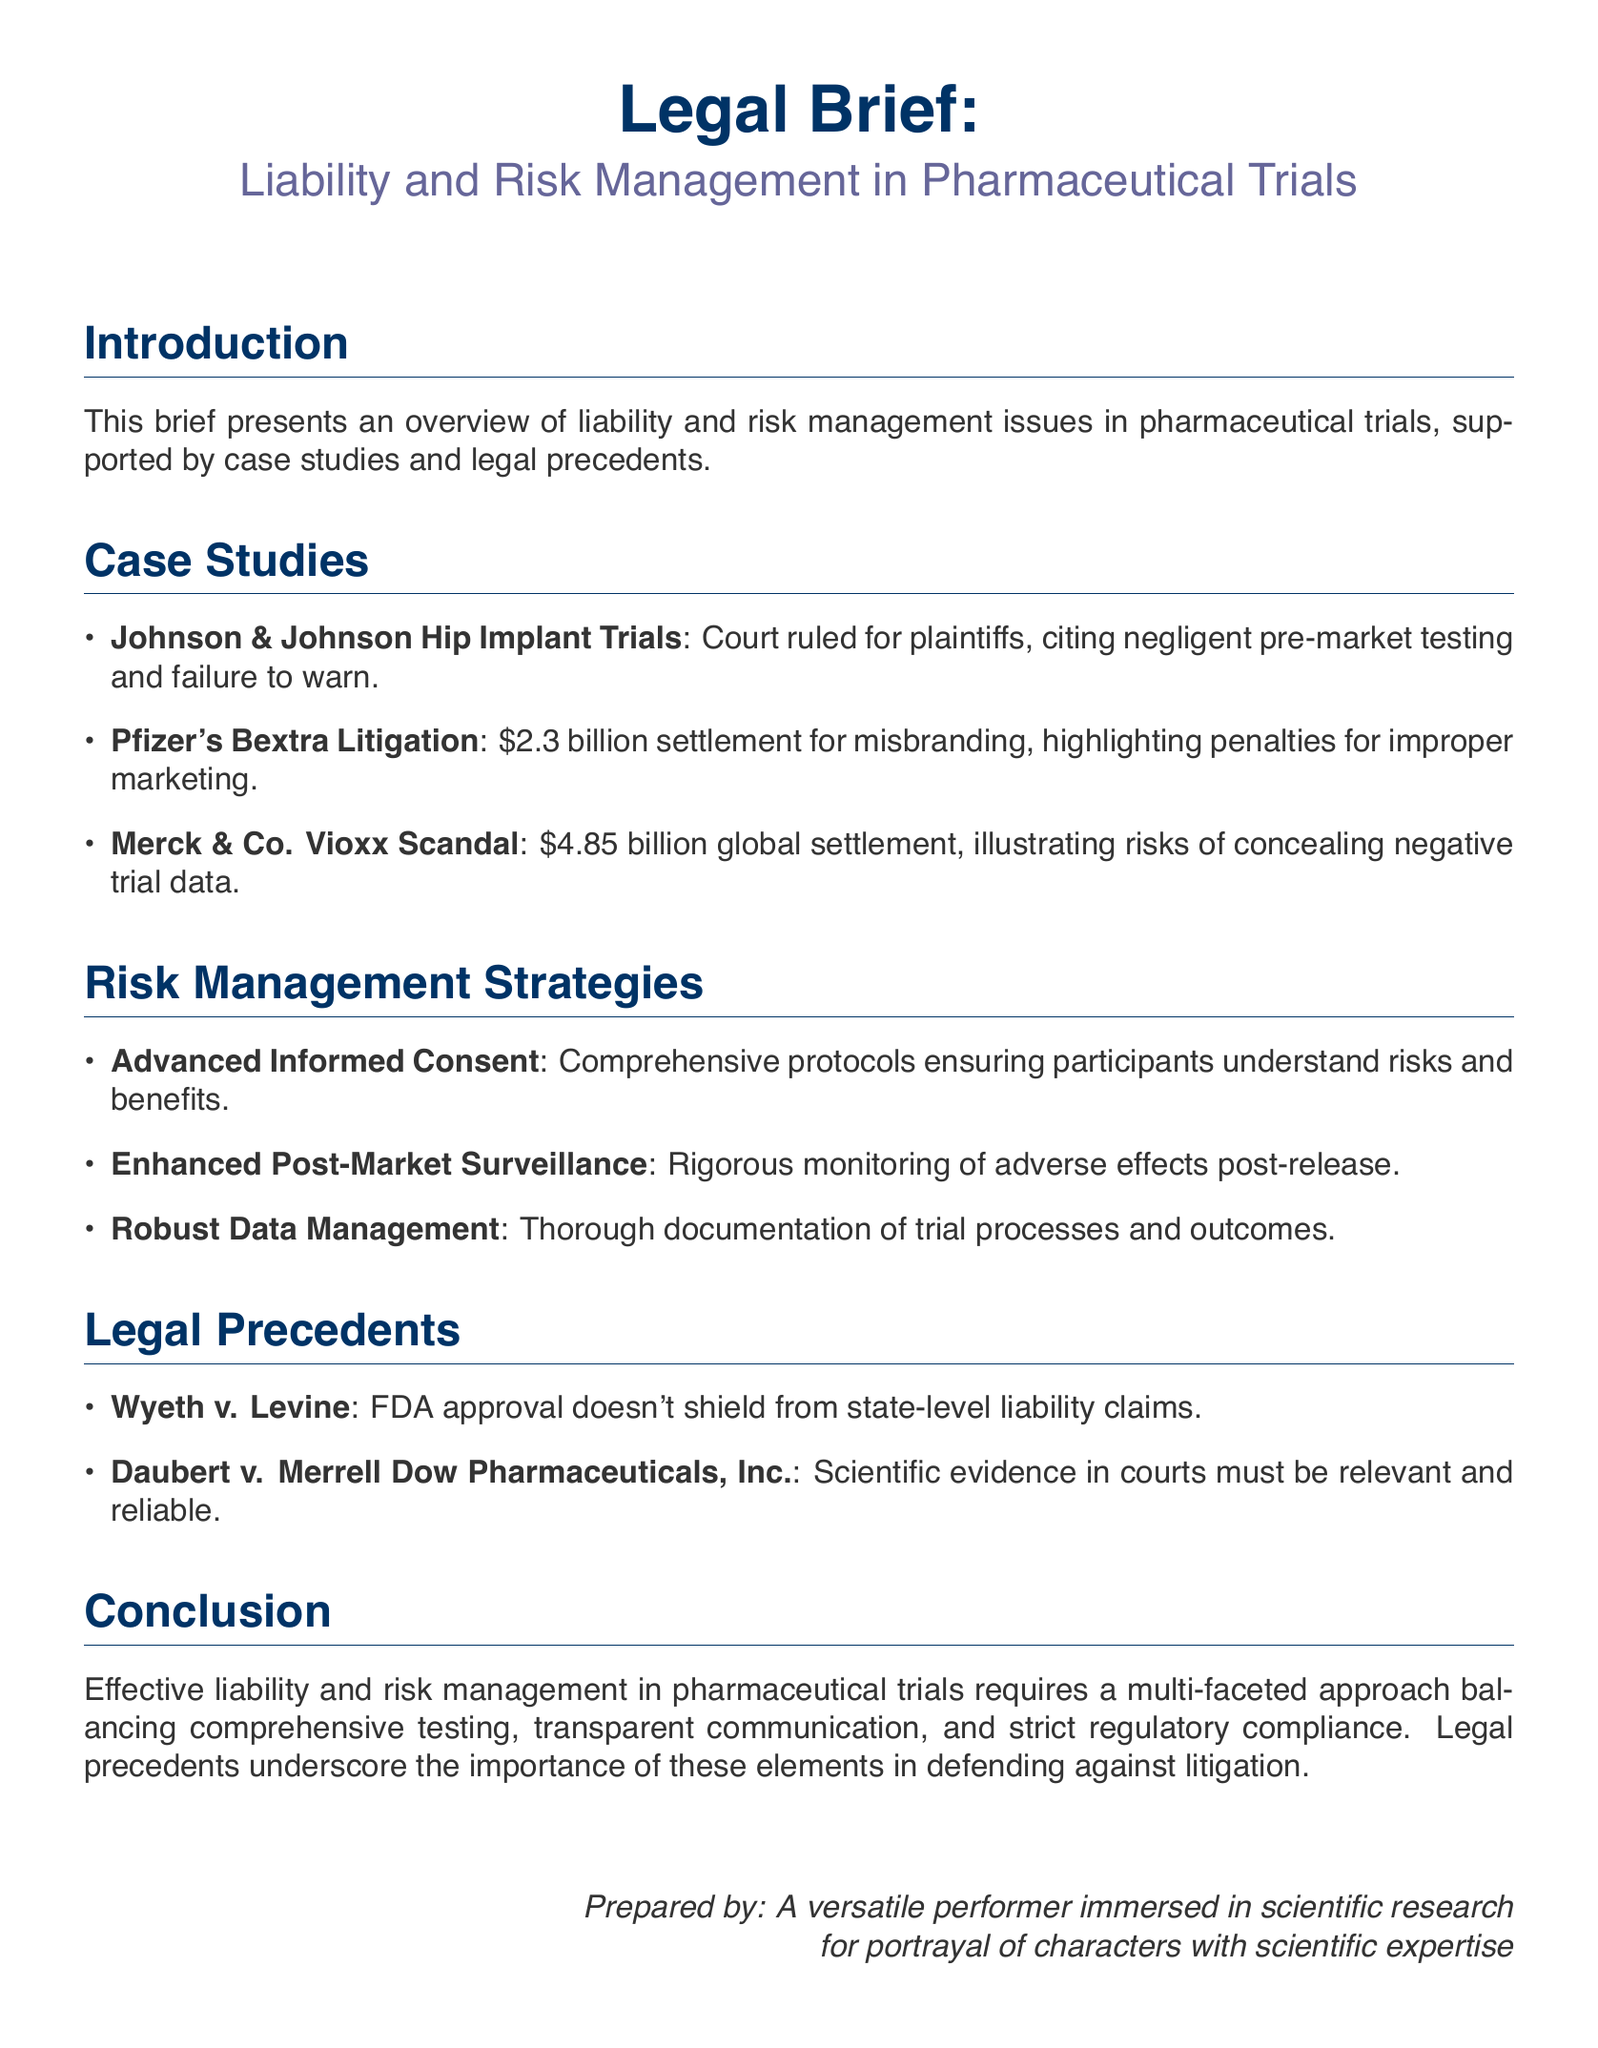What was the ruling in the Johnson & Johnson case? The court ruled for plaintiffs, citing negligent pre-market testing and failure to warn.
Answer: Plaintiffs What was the settlement amount for Pfizer's Bextra litigation? The document states a settlement of $2.3 billion for misbranding.
Answer: $2.3 billion What is one risk management strategy mentioned in the brief? The document lists "Advanced Informed Consent" as a strategy for risk management.
Answer: Advanced Informed Consent What does the Wyeth v. Levine case highlight? It highlights that FDA approval does not shield from state-level liability claims.
Answer: State-level liability claims What is a key element of effective liability management mentioned in the conclusion? The brief emphasizes "comprehensive testing" as a key element in managing liability.
Answer: Comprehensive testing What total amount was settled due to the Vioxx scandal? The document indicates a $4.85 billion global settlement related to the Vioxx scandal.
Answer: $4.85 billion What does the Daubert v. Merrell Dow Pharmaceuticals, Inc. case reference? It references that scientific evidence in courts must be relevant and reliable.
Answer: Relevant and reliable What is the focus of the first section of the document? The first section provides an overview of liability and risk management issues in pharmaceutical trials.
Answer: Overview of liability and risk management What multi-faceted approach is mentioned in the conclusion? The conclusion mentions the need for a multi-faceted approach balancing comprehensive testing and transparent communication.
Answer: Multi-faceted approach 